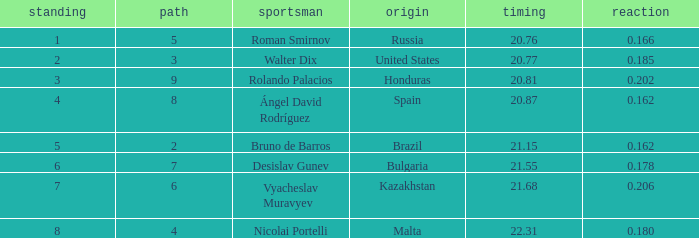What's Russia's lane when they were ranked before 1? None. 